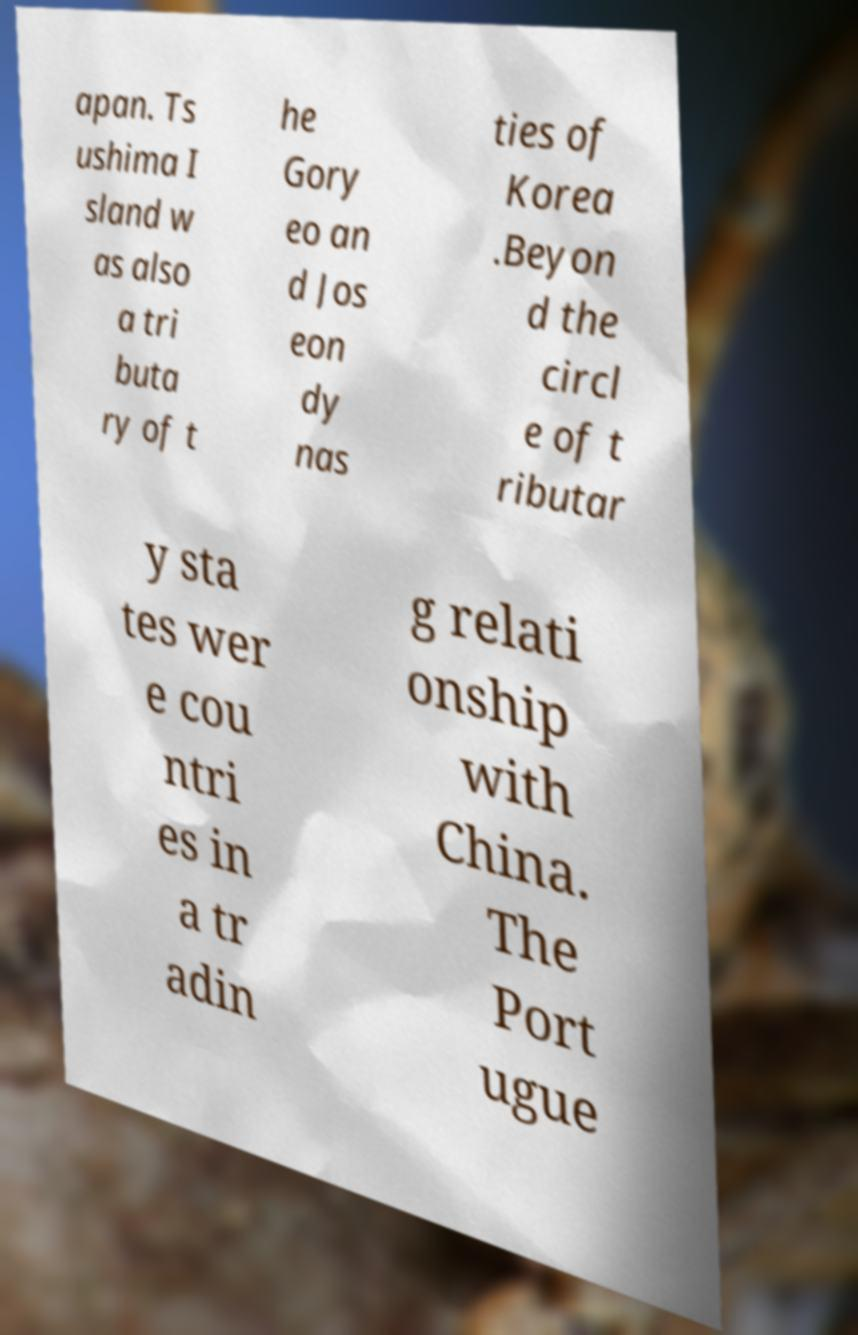Can you accurately transcribe the text from the provided image for me? apan. Ts ushima I sland w as also a tri buta ry of t he Gory eo an d Jos eon dy nas ties of Korea .Beyon d the circl e of t ributar y sta tes wer e cou ntri es in a tr adin g relati onship with China. The Port ugue 